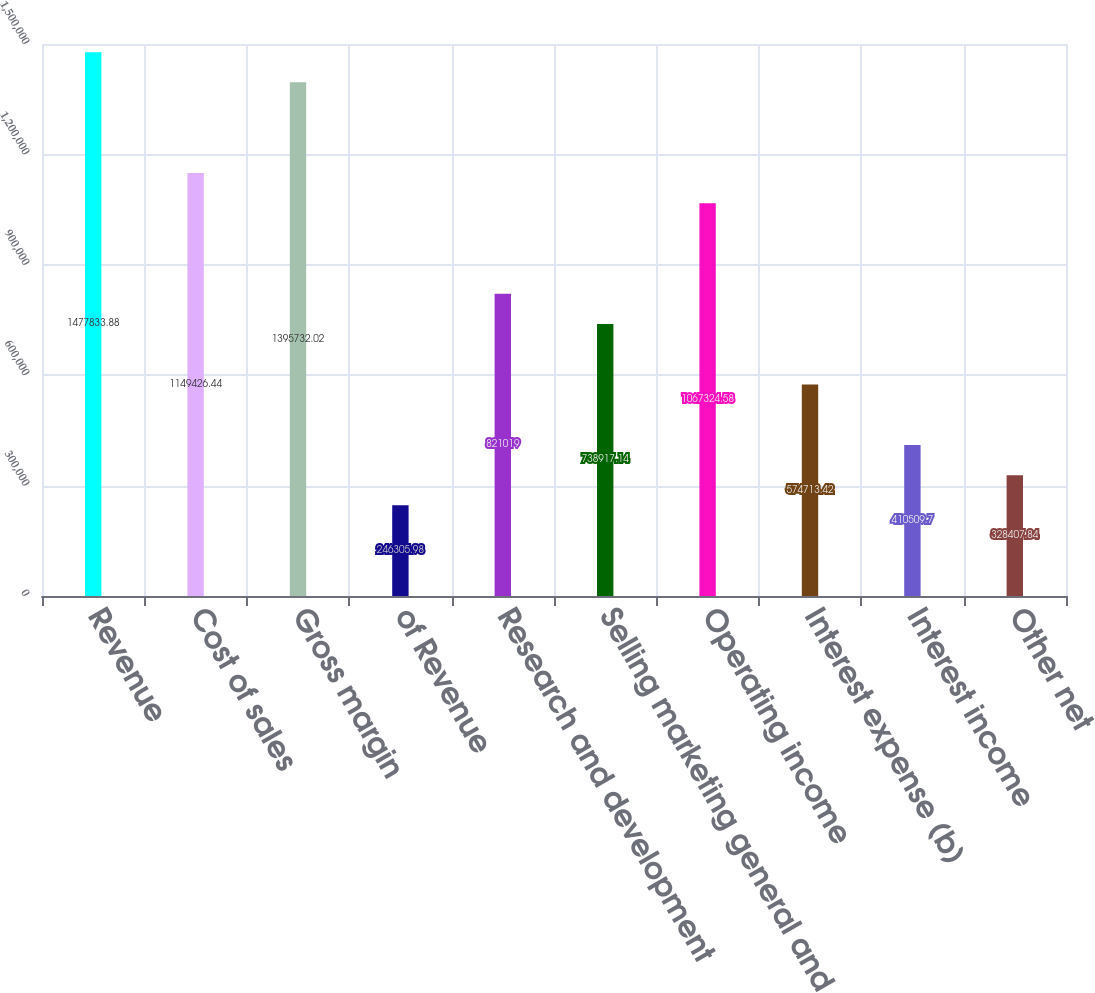Convert chart. <chart><loc_0><loc_0><loc_500><loc_500><bar_chart><fcel>Revenue<fcel>Cost of sales<fcel>Gross margin<fcel>of Revenue<fcel>Research and development<fcel>Selling marketing general and<fcel>Operating income<fcel>Interest expense (b)<fcel>Interest income<fcel>Other net<nl><fcel>1.47783e+06<fcel>1.14943e+06<fcel>1.39573e+06<fcel>246306<fcel>821019<fcel>738917<fcel>1.06732e+06<fcel>574713<fcel>410510<fcel>328408<nl></chart> 